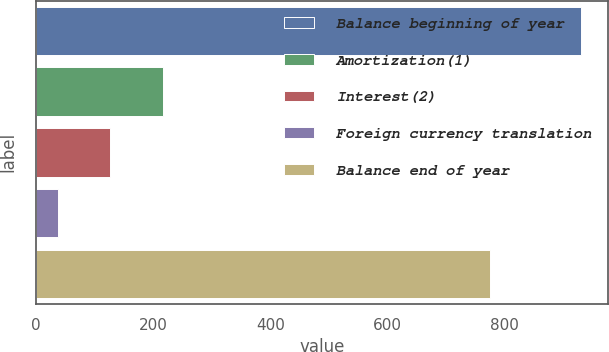Convert chart. <chart><loc_0><loc_0><loc_500><loc_500><bar_chart><fcel>Balance beginning of year<fcel>Amortization(1)<fcel>Interest(2)<fcel>Foreign currency translation<fcel>Balance end of year<nl><fcel>930<fcel>216.4<fcel>127.2<fcel>38<fcel>776<nl></chart> 